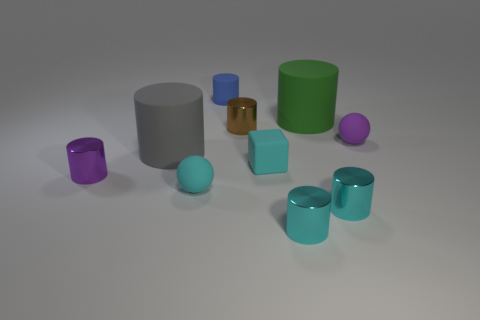How many other objects are the same shape as the blue object? In the image, there are five other objects sharing the same cylindrical shape as the blue cylinder: one gray, one purple, one green, and two smaller cyan ones. 